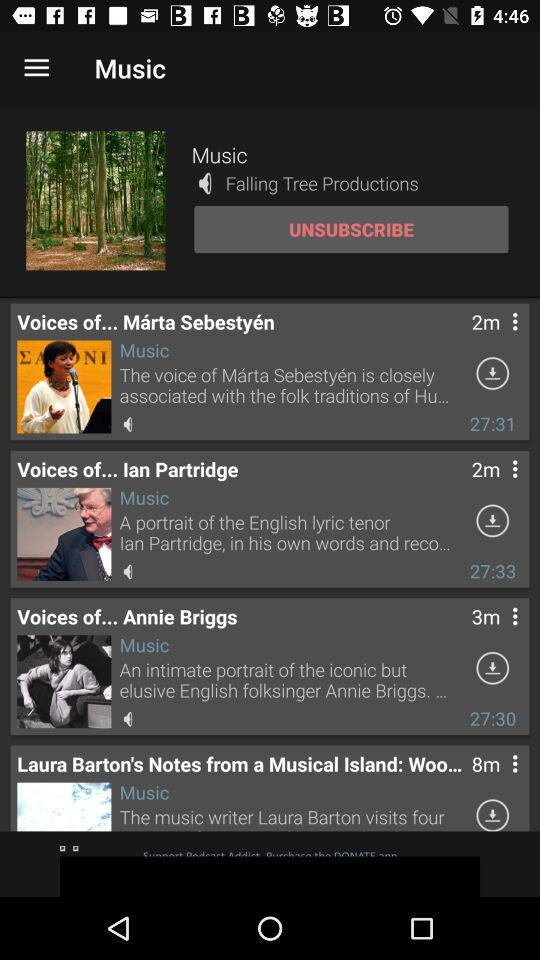What is the duration of the "Voices of... Annie Briggs" music? The duration of the music is 27:30. 